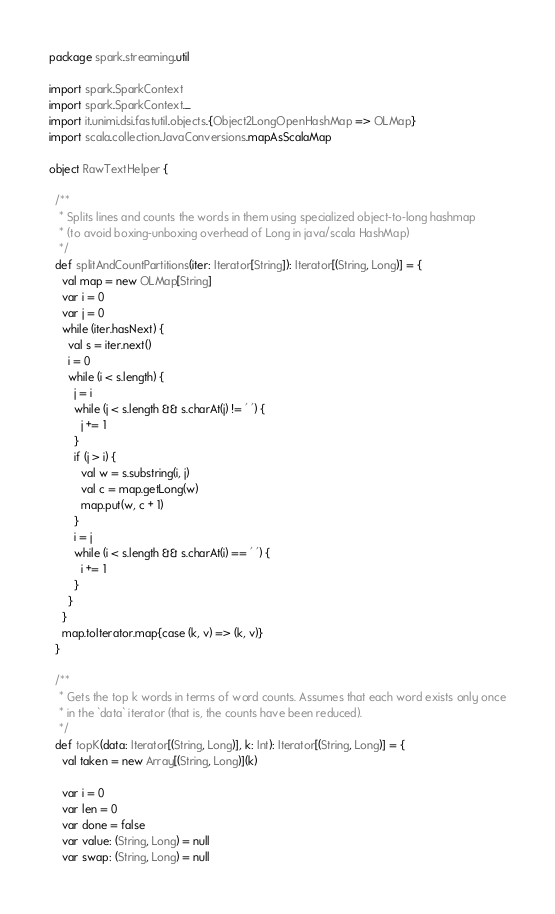Convert code to text. <code><loc_0><loc_0><loc_500><loc_500><_Scala_>package spark.streaming.util

import spark.SparkContext
import spark.SparkContext._
import it.unimi.dsi.fastutil.objects.{Object2LongOpenHashMap => OLMap}
import scala.collection.JavaConversions.mapAsScalaMap

object RawTextHelper {

  /** 
   * Splits lines and counts the words in them using specialized object-to-long hashmap 
   * (to avoid boxing-unboxing overhead of Long in java/scala HashMap)
   */
  def splitAndCountPartitions(iter: Iterator[String]): Iterator[(String, Long)] = {
    val map = new OLMap[String]
    var i = 0
    var j = 0
    while (iter.hasNext) {
      val s = iter.next()
      i = 0
      while (i < s.length) {
        j = i
        while (j < s.length && s.charAt(j) != ' ') {
          j += 1
        }
        if (j > i) {
          val w = s.substring(i, j)
          val c = map.getLong(w)
          map.put(w, c + 1)
        }
        i = j
        while (i < s.length && s.charAt(i) == ' ') {
          i += 1
        }
      }
    }
    map.toIterator.map{case (k, v) => (k, v)}
  }

  /** 
   * Gets the top k words in terms of word counts. Assumes that each word exists only once
   * in the `data` iterator (that is, the counts have been reduced).
   */
  def topK(data: Iterator[(String, Long)], k: Int): Iterator[(String, Long)] = {
    val taken = new Array[(String, Long)](k)
    
    var i = 0
    var len = 0
    var done = false
    var value: (String, Long) = null
    var swap: (String, Long) = null</code> 